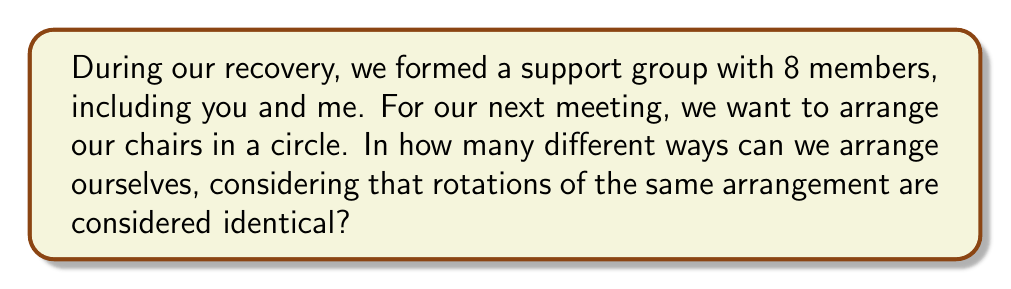Solve this math problem. Let's approach this step-by-step:

1) First, we need to recognize that this is a circular permutation problem. In circular permutations, rotations of the same arrangement are considered identical.

2) The formula for circular permutations of $n$ distinct objects is:

   $$(n-1)!$$

3) In this case, we have 8 members in total, so $n = 8$.

4) Plugging this into our formula:

   $$(8-1)! = 7!$$

5) Let's calculate 7!:
   
   $$7! = 7 \times 6 \times 5 \times 4 \times 3 \times 2 \times 1 = 5040$$

6) Therefore, there are 5040 different ways to arrange the 8 support group members in a circle.

Note: The reason we use $(n-1)!$ instead of $n!$ is because in a circular arrangement, we can fix the position of one person (say, yourself) and then arrange the rest of the $(n-1)$ people in $(n-1)!$ ways. Once we've done this, all possible circular arrangements have been counted.
Answer: 5040 